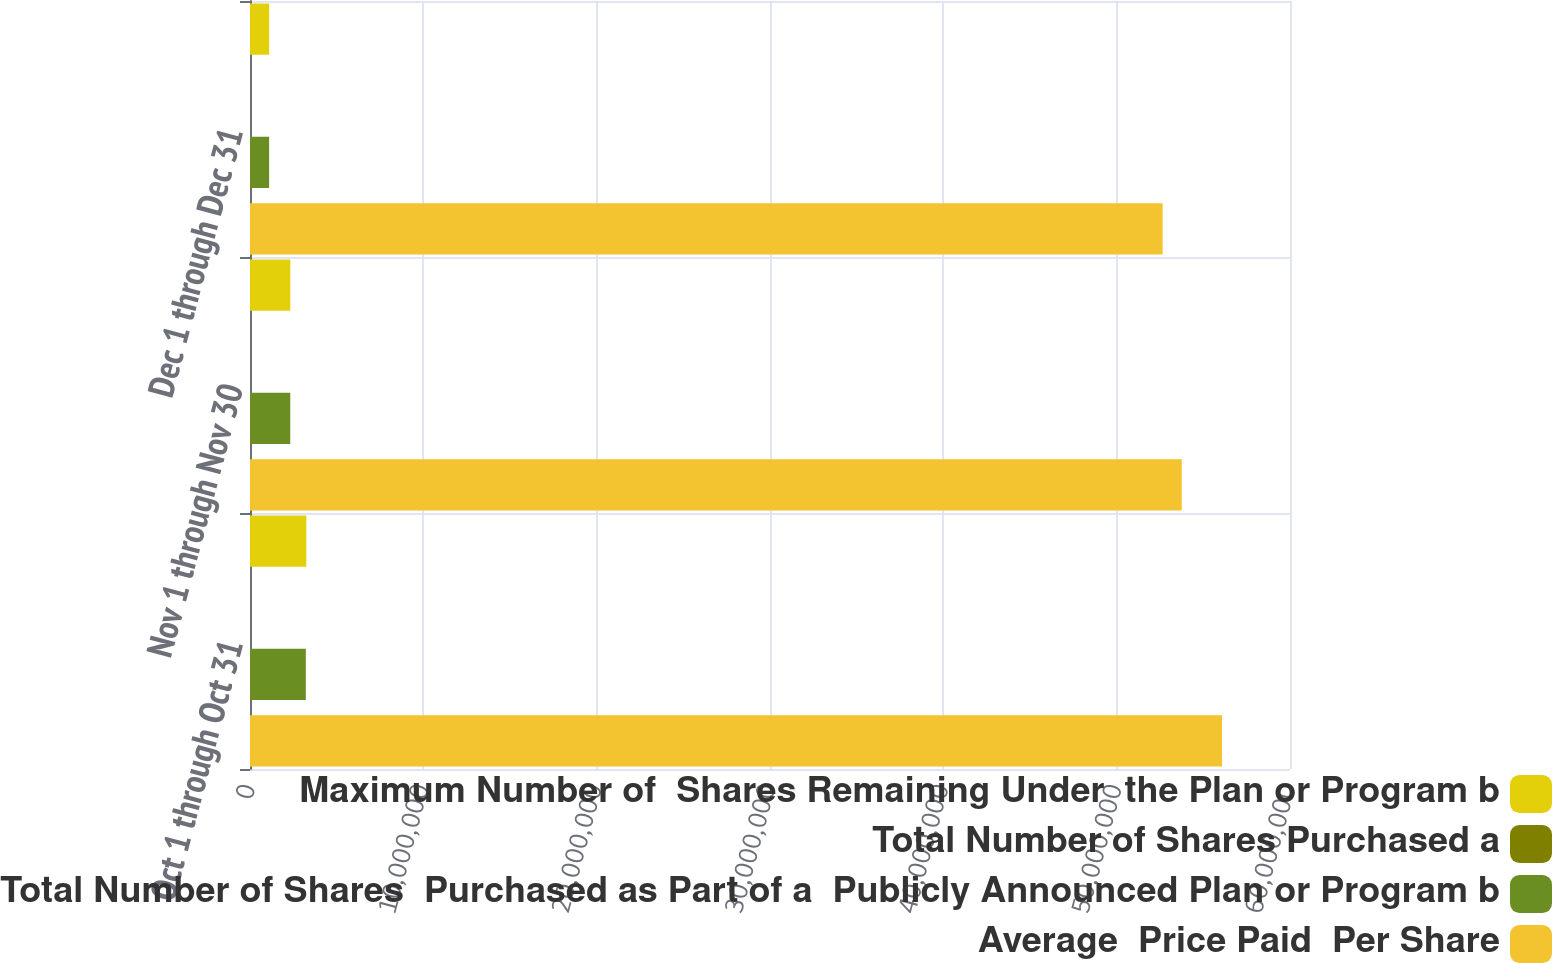Convert chart to OTSL. <chart><loc_0><loc_0><loc_500><loc_500><stacked_bar_chart><ecel><fcel>Oct 1 through Oct 31<fcel>Nov 1 through Nov 30<fcel>Dec 1 through Dec 31<nl><fcel>Maximum Number of  Shares Remaining Under  the Plan or Program b<fcel>3.24773e+06<fcel>2.32586e+06<fcel>1.10539e+06<nl><fcel>Total Number of Shares Purchased a<fcel>92.98<fcel>86.61<fcel>77.63<nl><fcel>Total Number of Shares  Purchased as Part of a  Publicly Announced Plan or Program b<fcel>3.22115e+06<fcel>2.32299e+06<fcel>1.10275e+06<nl><fcel>Average  Price Paid  Per Share<fcel>5.60782e+07<fcel>5.37552e+07<fcel>5.26524e+07<nl></chart> 